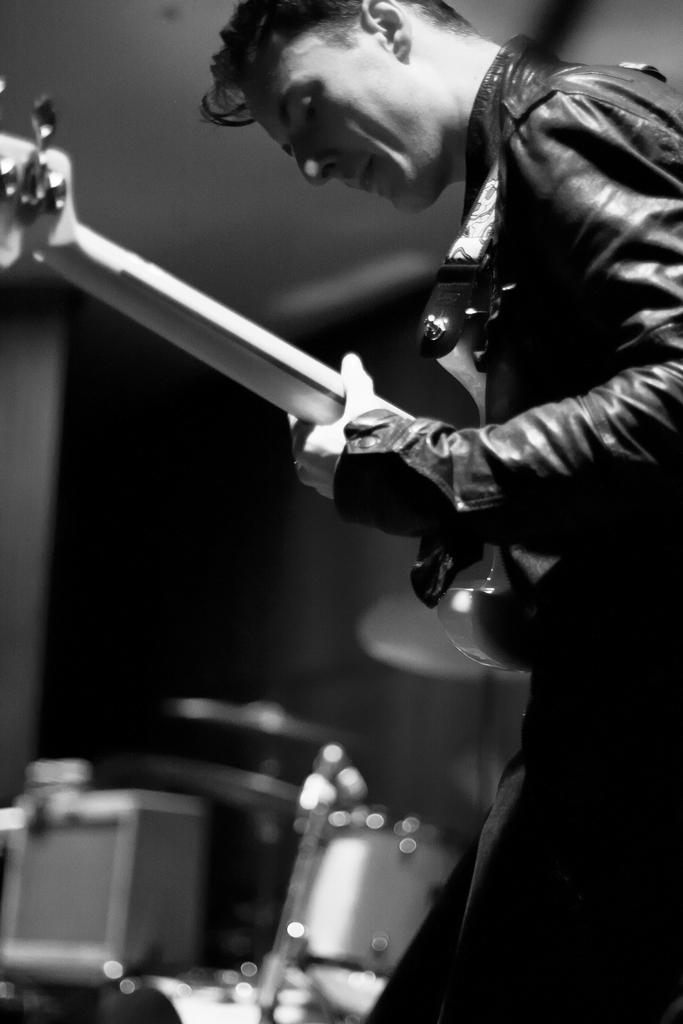What is the main subject of the image? There is a man in the image. What is the man doing in the image? The man is standing in the image. What object is the man holding in the image? The man is holding a guitar in the image. What type of clothing is the man wearing in the image? The man is wearing a jacket in the image. What can be seen in the background of the image? There is a drum set in the background of the image. Where is the shelf located in the image? There is no shelf present in the image. What type of map can be seen in the image? There is no map present in the image. 